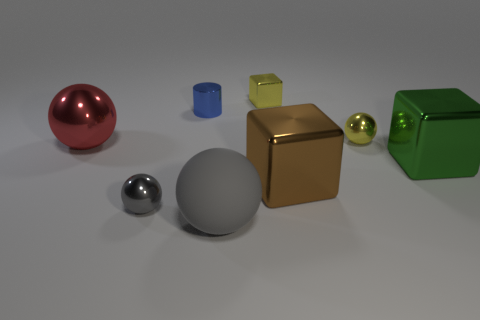Add 2 big blue matte objects. How many objects exist? 10 Subtract all cylinders. How many objects are left? 7 Subtract 0 brown spheres. How many objects are left? 8 Subtract all red metallic things. Subtract all small matte cubes. How many objects are left? 7 Add 8 tiny gray balls. How many tiny gray balls are left? 9 Add 3 yellow things. How many yellow things exist? 5 